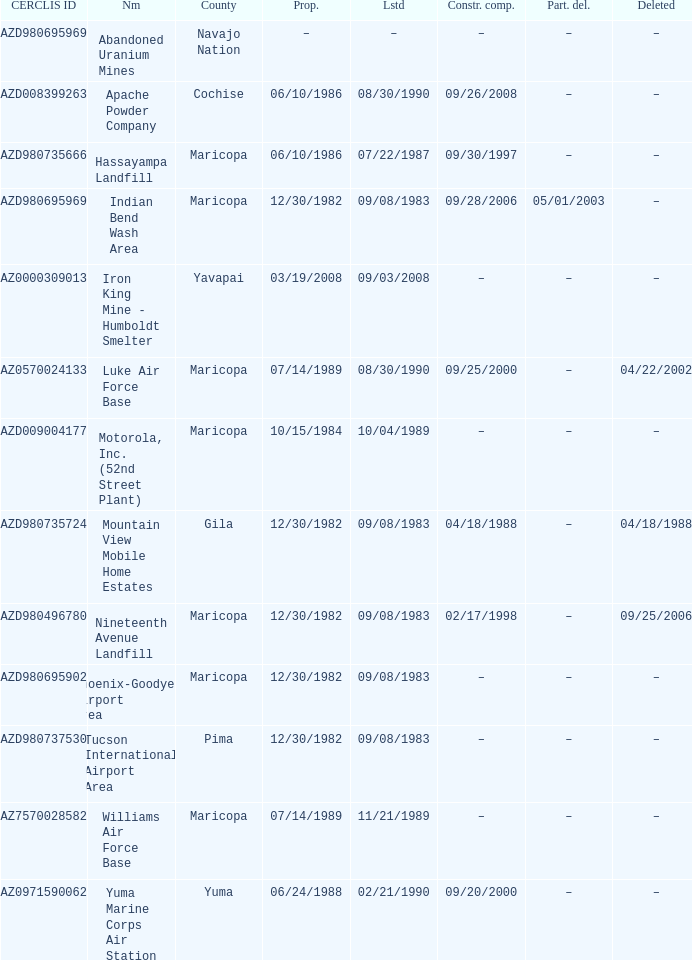When was the site listed when the county is cochise? 08/30/1990. 